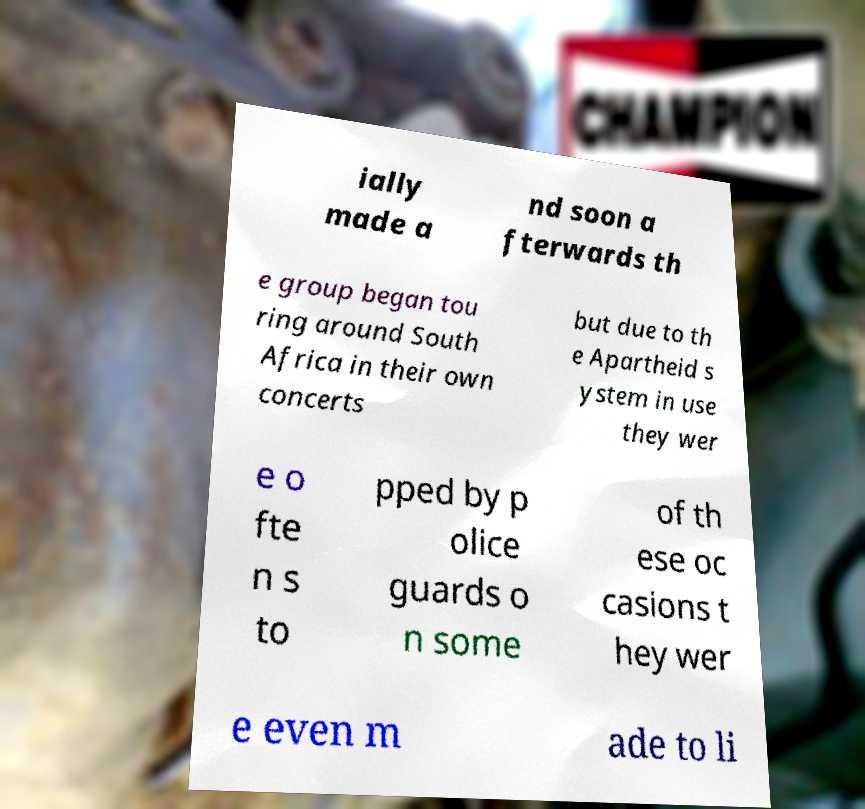There's text embedded in this image that I need extracted. Can you transcribe it verbatim? ially made a nd soon a fterwards th e group began tou ring around South Africa in their own concerts but due to th e Apartheid s ystem in use they wer e o fte n s to pped by p olice guards o n some of th ese oc casions t hey wer e even m ade to li 